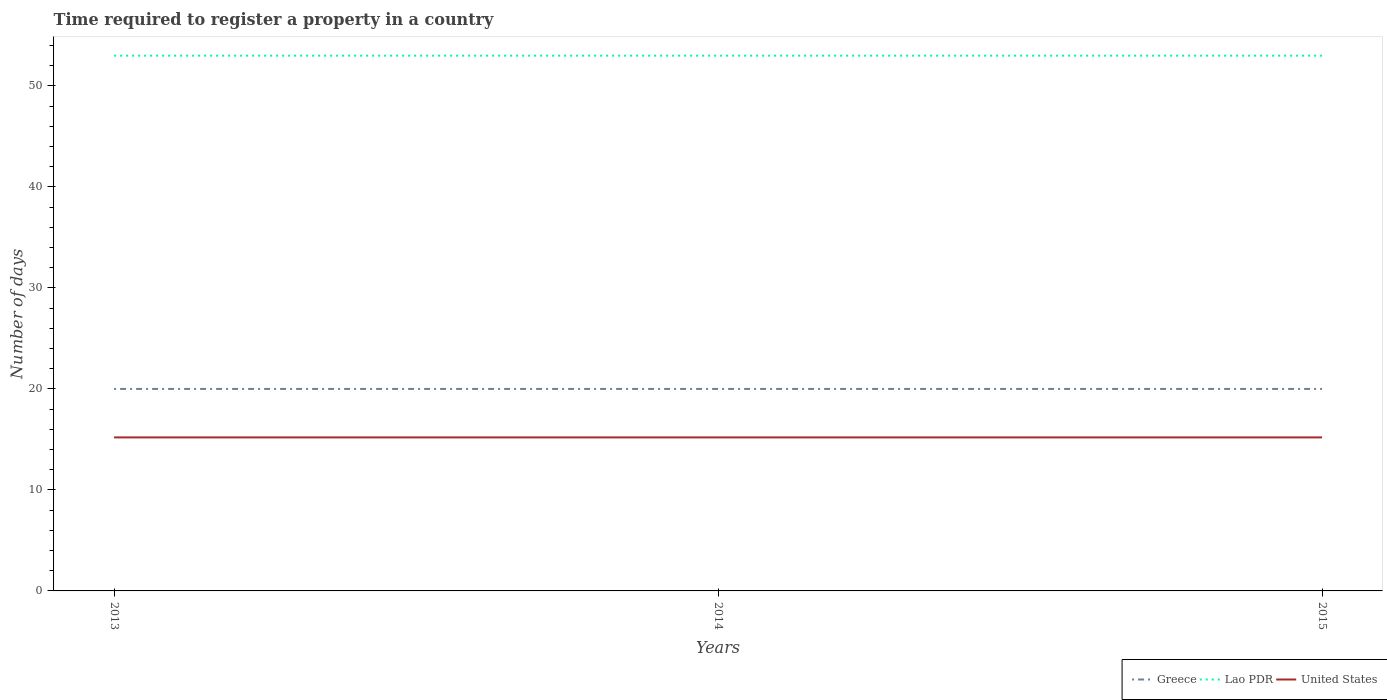Does the line corresponding to United States intersect with the line corresponding to Greece?
Ensure brevity in your answer.  No. Is the number of lines equal to the number of legend labels?
Provide a short and direct response. Yes. In which year was the number of days required to register a property in Greece maximum?
Make the answer very short. 2013. What is the difference between the highest and the second highest number of days required to register a property in Lao PDR?
Your response must be concise. 0. What is the difference between the highest and the lowest number of days required to register a property in United States?
Provide a short and direct response. 3. Is the number of days required to register a property in United States strictly greater than the number of days required to register a property in Greece over the years?
Offer a very short reply. Yes. How many lines are there?
Provide a succinct answer. 3. How many years are there in the graph?
Your answer should be very brief. 3. Does the graph contain grids?
Make the answer very short. No. Where does the legend appear in the graph?
Your answer should be very brief. Bottom right. How many legend labels are there?
Give a very brief answer. 3. What is the title of the graph?
Offer a very short reply. Time required to register a property in a country. What is the label or title of the Y-axis?
Your answer should be very brief. Number of days. What is the Number of days in United States in 2013?
Give a very brief answer. 15.2. What is the Number of days in Greece in 2014?
Your answer should be very brief. 20. What is the Number of days of Lao PDR in 2014?
Keep it short and to the point. 53. What is the Number of days of United States in 2014?
Your answer should be very brief. 15.2. What is the Number of days of Greece in 2015?
Provide a succinct answer. 20. Across all years, what is the maximum Number of days of Greece?
Provide a short and direct response. 20. Across all years, what is the maximum Number of days of Lao PDR?
Keep it short and to the point. 53. Across all years, what is the maximum Number of days in United States?
Ensure brevity in your answer.  15.2. Across all years, what is the minimum Number of days of Greece?
Provide a short and direct response. 20. Across all years, what is the minimum Number of days in United States?
Your answer should be compact. 15.2. What is the total Number of days in Lao PDR in the graph?
Your answer should be compact. 159. What is the total Number of days in United States in the graph?
Provide a short and direct response. 45.6. What is the difference between the Number of days in Lao PDR in 2013 and that in 2014?
Offer a terse response. 0. What is the difference between the Number of days in Greece in 2013 and that in 2015?
Ensure brevity in your answer.  0. What is the difference between the Number of days of Lao PDR in 2013 and that in 2015?
Your answer should be very brief. 0. What is the difference between the Number of days of United States in 2013 and that in 2015?
Make the answer very short. 0. What is the difference between the Number of days of United States in 2014 and that in 2015?
Your response must be concise. 0. What is the difference between the Number of days in Greece in 2013 and the Number of days in Lao PDR in 2014?
Your answer should be very brief. -33. What is the difference between the Number of days in Lao PDR in 2013 and the Number of days in United States in 2014?
Ensure brevity in your answer.  37.8. What is the difference between the Number of days of Greece in 2013 and the Number of days of Lao PDR in 2015?
Provide a short and direct response. -33. What is the difference between the Number of days of Lao PDR in 2013 and the Number of days of United States in 2015?
Your answer should be very brief. 37.8. What is the difference between the Number of days in Greece in 2014 and the Number of days in Lao PDR in 2015?
Provide a succinct answer. -33. What is the difference between the Number of days of Greece in 2014 and the Number of days of United States in 2015?
Your response must be concise. 4.8. What is the difference between the Number of days of Lao PDR in 2014 and the Number of days of United States in 2015?
Provide a succinct answer. 37.8. In the year 2013, what is the difference between the Number of days in Greece and Number of days in Lao PDR?
Offer a terse response. -33. In the year 2013, what is the difference between the Number of days in Lao PDR and Number of days in United States?
Your response must be concise. 37.8. In the year 2014, what is the difference between the Number of days of Greece and Number of days of Lao PDR?
Your answer should be compact. -33. In the year 2014, what is the difference between the Number of days of Lao PDR and Number of days of United States?
Offer a very short reply. 37.8. In the year 2015, what is the difference between the Number of days of Greece and Number of days of Lao PDR?
Give a very brief answer. -33. In the year 2015, what is the difference between the Number of days of Greece and Number of days of United States?
Keep it short and to the point. 4.8. In the year 2015, what is the difference between the Number of days of Lao PDR and Number of days of United States?
Ensure brevity in your answer.  37.8. What is the ratio of the Number of days of Lao PDR in 2013 to that in 2014?
Provide a short and direct response. 1. What is the ratio of the Number of days of Greece in 2013 to that in 2015?
Give a very brief answer. 1. What is the ratio of the Number of days of Lao PDR in 2013 to that in 2015?
Offer a very short reply. 1. What is the ratio of the Number of days in United States in 2013 to that in 2015?
Your answer should be compact. 1. What is the ratio of the Number of days of Greece in 2014 to that in 2015?
Give a very brief answer. 1. What is the ratio of the Number of days of United States in 2014 to that in 2015?
Keep it short and to the point. 1. What is the difference between the highest and the second highest Number of days in Greece?
Offer a terse response. 0. What is the difference between the highest and the second highest Number of days of Lao PDR?
Provide a short and direct response. 0. What is the difference between the highest and the second highest Number of days in United States?
Provide a short and direct response. 0. What is the difference between the highest and the lowest Number of days in Greece?
Your response must be concise. 0. What is the difference between the highest and the lowest Number of days of Lao PDR?
Your answer should be very brief. 0. What is the difference between the highest and the lowest Number of days of United States?
Offer a very short reply. 0. 